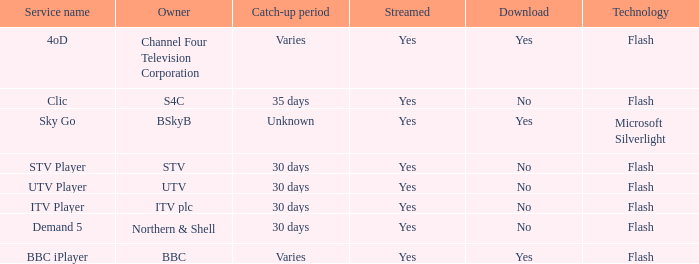What is the download of the varies catch-up period? Yes, Yes. 